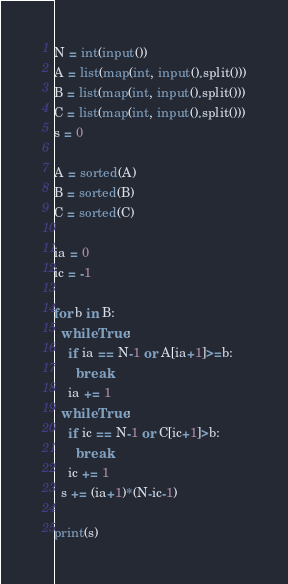<code> <loc_0><loc_0><loc_500><loc_500><_Python_>N = int(input())
A = list(map(int, input().split()))
B = list(map(int, input().split()))
C = list(map(int, input().split()))
s = 0

A = sorted(A)
B = sorted(B)
C = sorted(C)

ia = 0
ic = -1

for b in B:
  while True:
    if ia == N-1 or A[ia+1]>=b: 
      break
    ia += 1
  while True:
    if ic == N-1 or C[ic+1]>b:
      break
    ic += 1
  s += (ia+1)*(N-ic-1)
    
print(s)</code> 